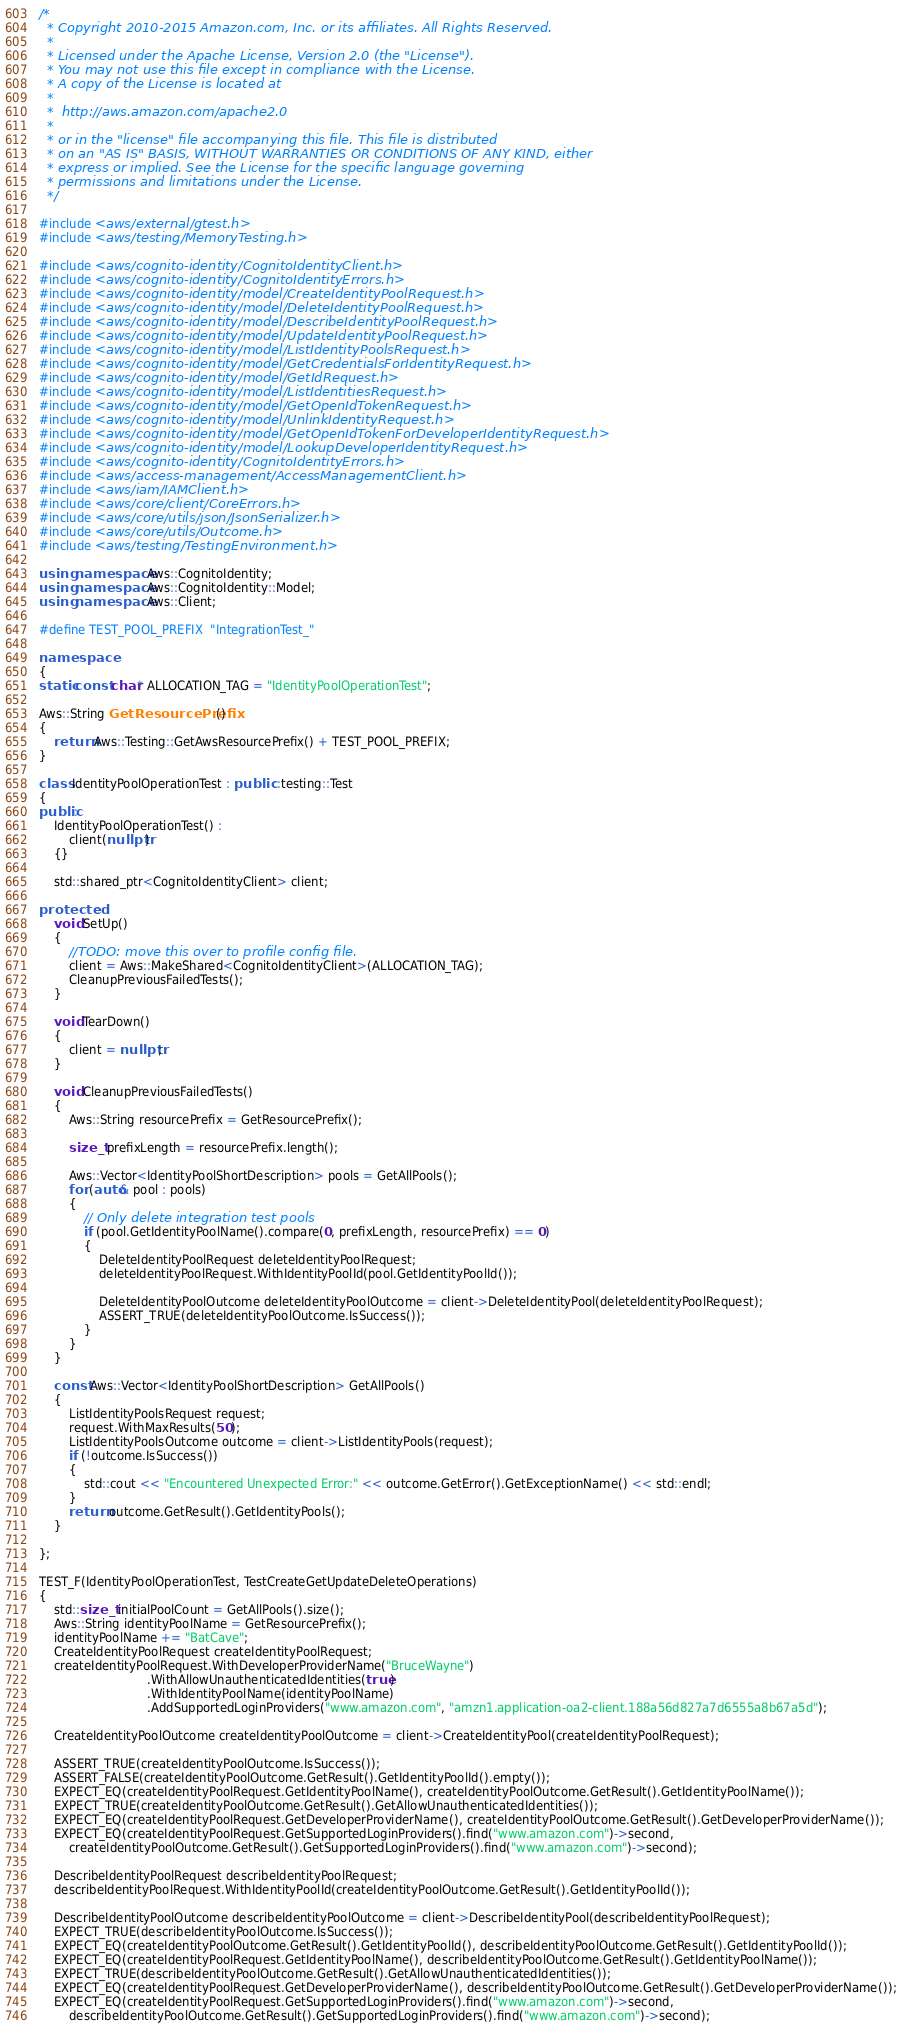<code> <loc_0><loc_0><loc_500><loc_500><_C++_>/*
  * Copyright 2010-2015 Amazon.com, Inc. or its affiliates. All Rights Reserved.
  * 
  * Licensed under the Apache License, Version 2.0 (the "License").
  * You may not use this file except in compliance with the License.
  * A copy of the License is located at
  * 
  *  http://aws.amazon.com/apache2.0
  * 
  * or in the "license" file accompanying this file. This file is distributed
  * on an "AS IS" BASIS, WITHOUT WARRANTIES OR CONDITIONS OF ANY KIND, either
  * express or implied. See the License for the specific language governing
  * permissions and limitations under the License.
  */

#include <aws/external/gtest.h>
#include <aws/testing/MemoryTesting.h>

#include <aws/cognito-identity/CognitoIdentityClient.h>
#include <aws/cognito-identity/CognitoIdentityErrors.h>
#include <aws/cognito-identity/model/CreateIdentityPoolRequest.h>
#include <aws/cognito-identity/model/DeleteIdentityPoolRequest.h>
#include <aws/cognito-identity/model/DescribeIdentityPoolRequest.h>
#include <aws/cognito-identity/model/UpdateIdentityPoolRequest.h>
#include <aws/cognito-identity/model/ListIdentityPoolsRequest.h>
#include <aws/cognito-identity/model/GetCredentialsForIdentityRequest.h>
#include <aws/cognito-identity/model/GetIdRequest.h>
#include <aws/cognito-identity/model/ListIdentitiesRequest.h>
#include <aws/cognito-identity/model/GetOpenIdTokenRequest.h>
#include <aws/cognito-identity/model/UnlinkIdentityRequest.h>
#include <aws/cognito-identity/model/GetOpenIdTokenForDeveloperIdentityRequest.h>
#include <aws/cognito-identity/model/LookupDeveloperIdentityRequest.h>
#include <aws/cognito-identity/CognitoIdentityErrors.h>
#include <aws/access-management/AccessManagementClient.h>
#include <aws/iam/IAMClient.h>
#include <aws/core/client/CoreErrors.h>
#include <aws/core/utils/json/JsonSerializer.h>
#include <aws/core/utils/Outcome.h>
#include <aws/testing/TestingEnvironment.h>

using namespace Aws::CognitoIdentity;
using namespace Aws::CognitoIdentity::Model;
using namespace Aws::Client;

#define TEST_POOL_PREFIX  "IntegrationTest_"

namespace
{
static const char* ALLOCATION_TAG = "IdentityPoolOperationTest";

Aws::String GetResourcePrefix()
{
    return Aws::Testing::GetAwsResourcePrefix() + TEST_POOL_PREFIX;
}

class IdentityPoolOperationTest : public ::testing::Test
{
public:
    IdentityPoolOperationTest() :
        client(nullptr)
    {}

    std::shared_ptr<CognitoIdentityClient> client;

protected:
    void SetUp()
    {
        //TODO: move this over to profile config file.
        client = Aws::MakeShared<CognitoIdentityClient>(ALLOCATION_TAG);
        CleanupPreviousFailedTests();
    }

    void TearDown()
    {
        client = nullptr;
    }

    void CleanupPreviousFailedTests()
    {
        Aws::String resourcePrefix = GetResourcePrefix();

        size_t prefixLength = resourcePrefix.length();

        Aws::Vector<IdentityPoolShortDescription> pools = GetAllPools();
        for (auto& pool : pools)
        {
            // Only delete integration test pools
            if (pool.GetIdentityPoolName().compare(0, prefixLength, resourcePrefix) == 0)
            {
                DeleteIdentityPoolRequest deleteIdentityPoolRequest;
                deleteIdentityPoolRequest.WithIdentityPoolId(pool.GetIdentityPoolId());

                DeleteIdentityPoolOutcome deleteIdentityPoolOutcome = client->DeleteIdentityPool(deleteIdentityPoolRequest);
                ASSERT_TRUE(deleteIdentityPoolOutcome.IsSuccess());
            }
        }
    }

    const Aws::Vector<IdentityPoolShortDescription> GetAllPools()
    {
        ListIdentityPoolsRequest request;
        request.WithMaxResults(50);
        ListIdentityPoolsOutcome outcome = client->ListIdentityPools(request);
        if (!outcome.IsSuccess())
        {
            std::cout << "Encountered Unexpected Error:" << outcome.GetError().GetExceptionName() << std::endl;
        }
        return outcome.GetResult().GetIdentityPools();
    }

};

TEST_F(IdentityPoolOperationTest, TestCreateGetUpdateDeleteOperations)
{
    std::size_t initialPoolCount = GetAllPools().size();
    Aws::String identityPoolName = GetResourcePrefix();
    identityPoolName += "BatCave";
    CreateIdentityPoolRequest createIdentityPoolRequest;
    createIdentityPoolRequest.WithDeveloperProviderName("BruceWayne")
                             .WithAllowUnauthenticatedIdentities(true)
                             .WithIdentityPoolName(identityPoolName)
                             .AddSupportedLoginProviders("www.amazon.com", "amzn1.application-oa2-client.188a56d827a7d6555a8b67a5d");

    CreateIdentityPoolOutcome createIdentityPoolOutcome = client->CreateIdentityPool(createIdentityPoolRequest);

    ASSERT_TRUE(createIdentityPoolOutcome.IsSuccess());
    ASSERT_FALSE(createIdentityPoolOutcome.GetResult().GetIdentityPoolId().empty());
    EXPECT_EQ(createIdentityPoolRequest.GetIdentityPoolName(), createIdentityPoolOutcome.GetResult().GetIdentityPoolName());
    EXPECT_TRUE(createIdentityPoolOutcome.GetResult().GetAllowUnauthenticatedIdentities());
    EXPECT_EQ(createIdentityPoolRequest.GetDeveloperProviderName(), createIdentityPoolOutcome.GetResult().GetDeveloperProviderName());
    EXPECT_EQ(createIdentityPoolRequest.GetSupportedLoginProviders().find("www.amazon.com")->second,
        createIdentityPoolOutcome.GetResult().GetSupportedLoginProviders().find("www.amazon.com")->second);

    DescribeIdentityPoolRequest describeIdentityPoolRequest;
    describeIdentityPoolRequest.WithIdentityPoolId(createIdentityPoolOutcome.GetResult().GetIdentityPoolId());

    DescribeIdentityPoolOutcome describeIdentityPoolOutcome = client->DescribeIdentityPool(describeIdentityPoolRequest);
    EXPECT_TRUE(describeIdentityPoolOutcome.IsSuccess());
    EXPECT_EQ(createIdentityPoolOutcome.GetResult().GetIdentityPoolId(), describeIdentityPoolOutcome.GetResult().GetIdentityPoolId());
    EXPECT_EQ(createIdentityPoolRequest.GetIdentityPoolName(), describeIdentityPoolOutcome.GetResult().GetIdentityPoolName());
    EXPECT_TRUE(describeIdentityPoolOutcome.GetResult().GetAllowUnauthenticatedIdentities());
    EXPECT_EQ(createIdentityPoolRequest.GetDeveloperProviderName(), describeIdentityPoolOutcome.GetResult().GetDeveloperProviderName());
    EXPECT_EQ(createIdentityPoolRequest.GetSupportedLoginProviders().find("www.amazon.com")->second,
        describeIdentityPoolOutcome.GetResult().GetSupportedLoginProviders().find("www.amazon.com")->second);</code> 